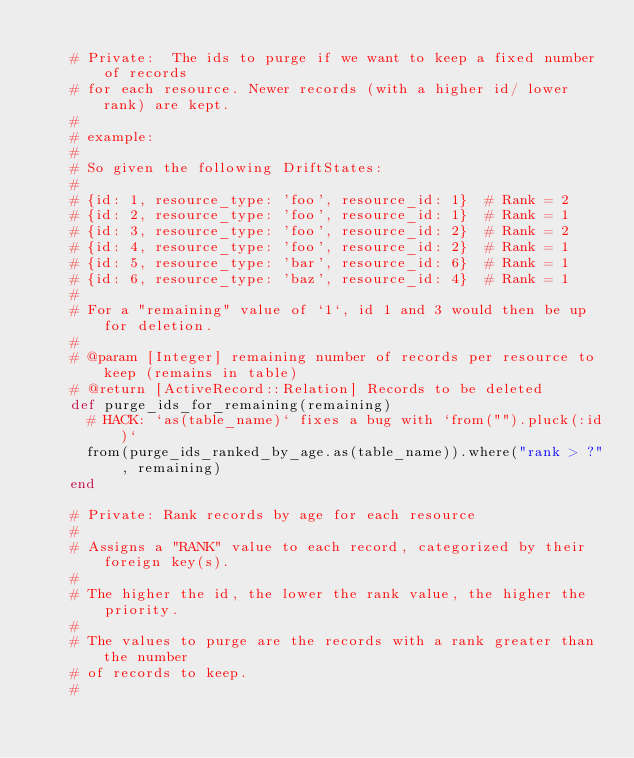Convert code to text. <code><loc_0><loc_0><loc_500><loc_500><_Ruby_>
    # Private:  The ids to purge if we want to keep a fixed number of records
    # for each resource. Newer records (with a higher id/ lower rank) are kept.
    #
    # example:
    #
    # So given the following DriftStates:
    #
    # {id: 1, resource_type: 'foo', resource_id: 1}  # Rank = 2
    # {id: 2, resource_type: 'foo', resource_id: 1}  # Rank = 1
    # {id: 3, resource_type: 'foo', resource_id: 2}  # Rank = 2
    # {id: 4, resource_type: 'foo', resource_id: 2}  # Rank = 1
    # {id: 5, resource_type: 'bar', resource_id: 6}  # Rank = 1
    # {id: 6, resource_type: 'baz', resource_id: 4}  # Rank = 1
    #
    # For a "remaining" value of `1`, id 1 and 3 would then be up for deletion.
    #
    # @param [Integer] remaining number of records per resource to keep (remains in table)
    # @return [ActiveRecord::Relation] Records to be deleted
    def purge_ids_for_remaining(remaining)
      # HACK: `as(table_name)` fixes a bug with `from("").pluck(:id)`
      from(purge_ids_ranked_by_age.as(table_name)).where("rank > ?", remaining)
    end

    # Private: Rank records by age for each resource
    #
    # Assigns a "RANK" value to each record, categorized by their foreign key(s).
    #
    # The higher the id, the lower the rank value, the higher the priority.
    #
    # The values to purge are the records with a rank greater than the number
    # of records to keep.
    #</code> 